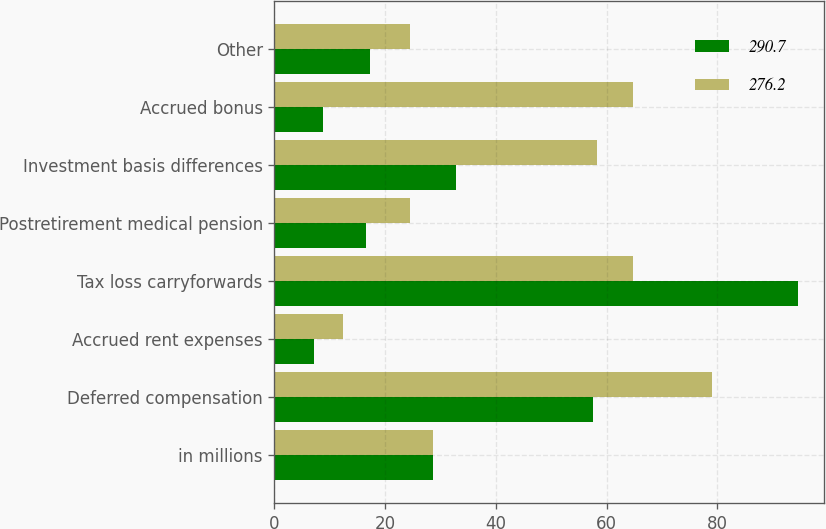Convert chart. <chart><loc_0><loc_0><loc_500><loc_500><stacked_bar_chart><ecel><fcel>in millions<fcel>Deferred compensation<fcel>Accrued rent expenses<fcel>Tax loss carryforwards<fcel>Postretirement medical pension<fcel>Investment basis differences<fcel>Accrued bonus<fcel>Other<nl><fcel>290.7<fcel>28.65<fcel>57.6<fcel>7.2<fcel>94.6<fcel>16.6<fcel>32.8<fcel>8.8<fcel>17.2<nl><fcel>276.2<fcel>28.65<fcel>79.1<fcel>12.3<fcel>64.8<fcel>24.4<fcel>58.3<fcel>64.8<fcel>24.5<nl></chart> 